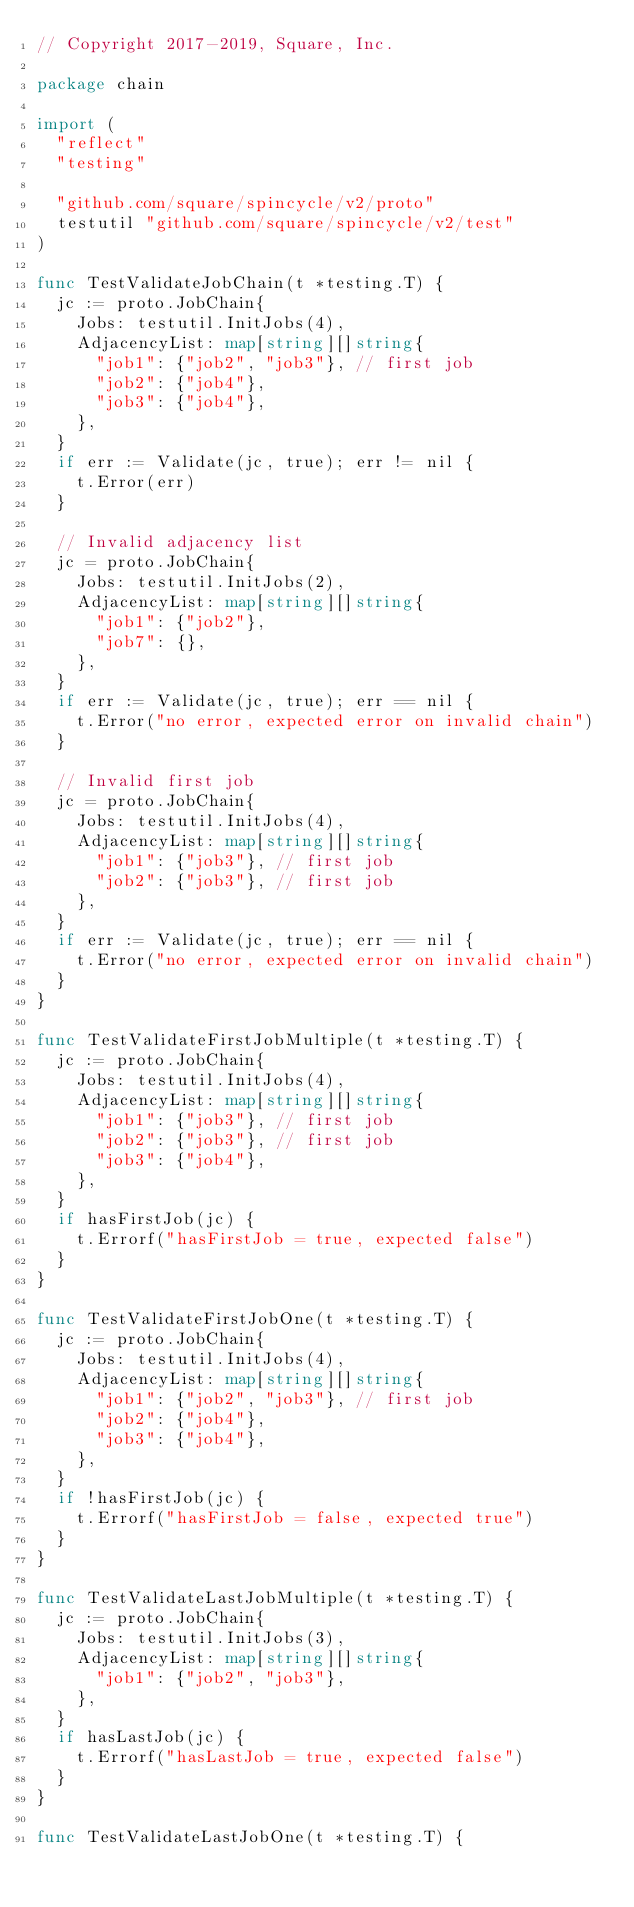<code> <loc_0><loc_0><loc_500><loc_500><_Go_>// Copyright 2017-2019, Square, Inc.

package chain

import (
	"reflect"
	"testing"

	"github.com/square/spincycle/v2/proto"
	testutil "github.com/square/spincycle/v2/test"
)

func TestValidateJobChain(t *testing.T) {
	jc := proto.JobChain{
		Jobs: testutil.InitJobs(4),
		AdjacencyList: map[string][]string{
			"job1": {"job2", "job3"}, // first job
			"job2": {"job4"},
			"job3": {"job4"},
		},
	}
	if err := Validate(jc, true); err != nil {
		t.Error(err)
	}

	// Invalid adjacency list
	jc = proto.JobChain{
		Jobs: testutil.InitJobs(2),
		AdjacencyList: map[string][]string{
			"job1": {"job2"},
			"job7": {},
		},
	}
	if err := Validate(jc, true); err == nil {
		t.Error("no error, expected error on invalid chain")
	}

	// Invalid first job
	jc = proto.JobChain{
		Jobs: testutil.InitJobs(4),
		AdjacencyList: map[string][]string{
			"job1": {"job3"}, // first job
			"job2": {"job3"}, // first job
		},
	}
	if err := Validate(jc, true); err == nil {
		t.Error("no error, expected error on invalid chain")
	}
}

func TestValidateFirstJobMultiple(t *testing.T) {
	jc := proto.JobChain{
		Jobs: testutil.InitJobs(4),
		AdjacencyList: map[string][]string{
			"job1": {"job3"}, // first job
			"job2": {"job3"}, // first job
			"job3": {"job4"},
		},
	}
	if hasFirstJob(jc) {
		t.Errorf("hasFirstJob = true, expected false")
	}
}

func TestValidateFirstJobOne(t *testing.T) {
	jc := proto.JobChain{
		Jobs: testutil.InitJobs(4),
		AdjacencyList: map[string][]string{
			"job1": {"job2", "job3"}, // first job
			"job2": {"job4"},
			"job3": {"job4"},
		},
	}
	if !hasFirstJob(jc) {
		t.Errorf("hasFirstJob = false, expected true")
	}
}

func TestValidateLastJobMultiple(t *testing.T) {
	jc := proto.JobChain{
		Jobs: testutil.InitJobs(3),
		AdjacencyList: map[string][]string{
			"job1": {"job2", "job3"},
		},
	}
	if hasLastJob(jc) {
		t.Errorf("hasLastJob = true, expected false")
	}
}

func TestValidateLastJobOne(t *testing.T) {</code> 